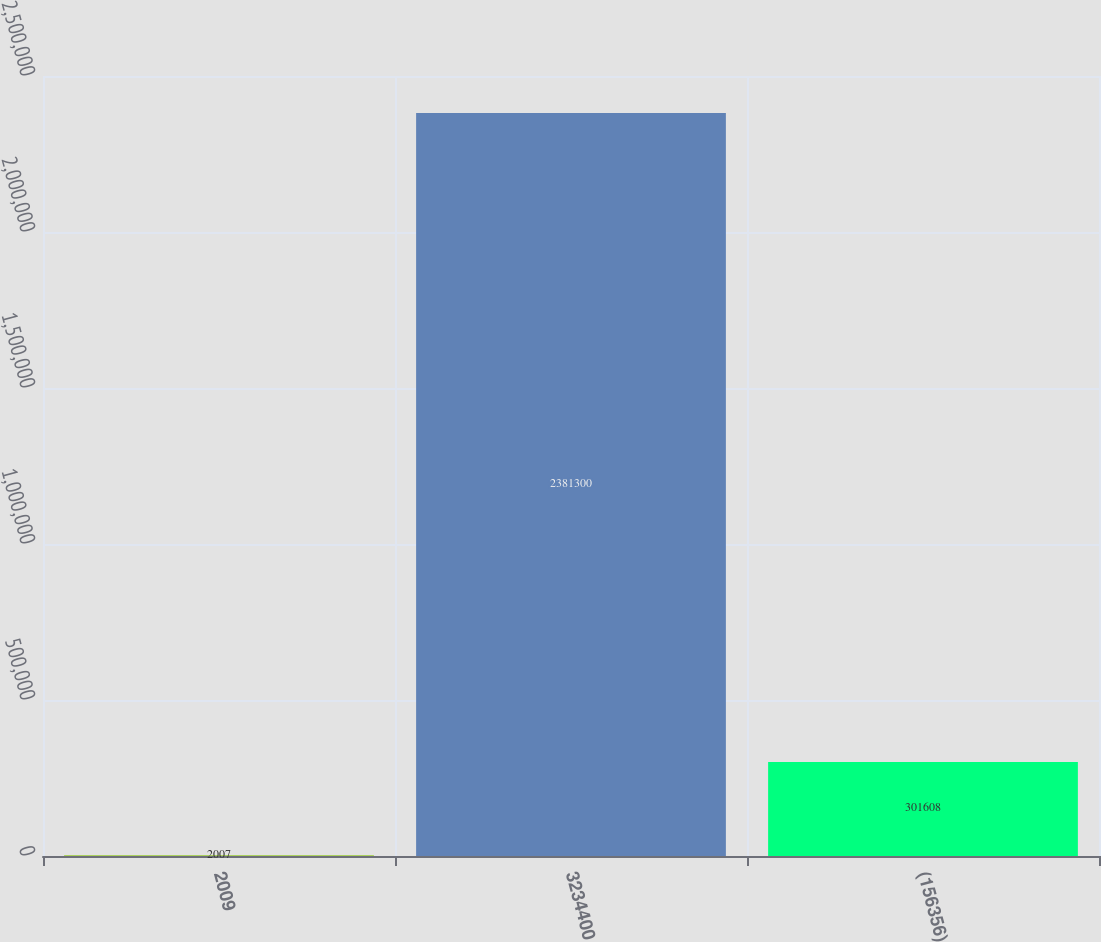Convert chart. <chart><loc_0><loc_0><loc_500><loc_500><bar_chart><fcel>2009<fcel>3234400<fcel>(156356)<nl><fcel>2007<fcel>2.3813e+06<fcel>301608<nl></chart> 